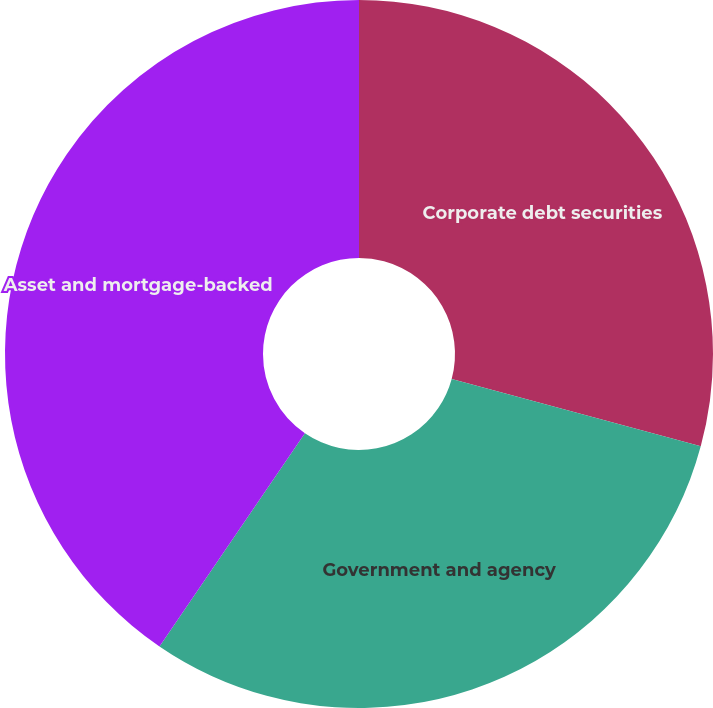Convert chart. <chart><loc_0><loc_0><loc_500><loc_500><pie_chart><fcel>Corporate debt securities<fcel>Government and agency<fcel>Asset and mortgage-backed<nl><fcel>29.2%<fcel>30.33%<fcel>40.47%<nl></chart> 